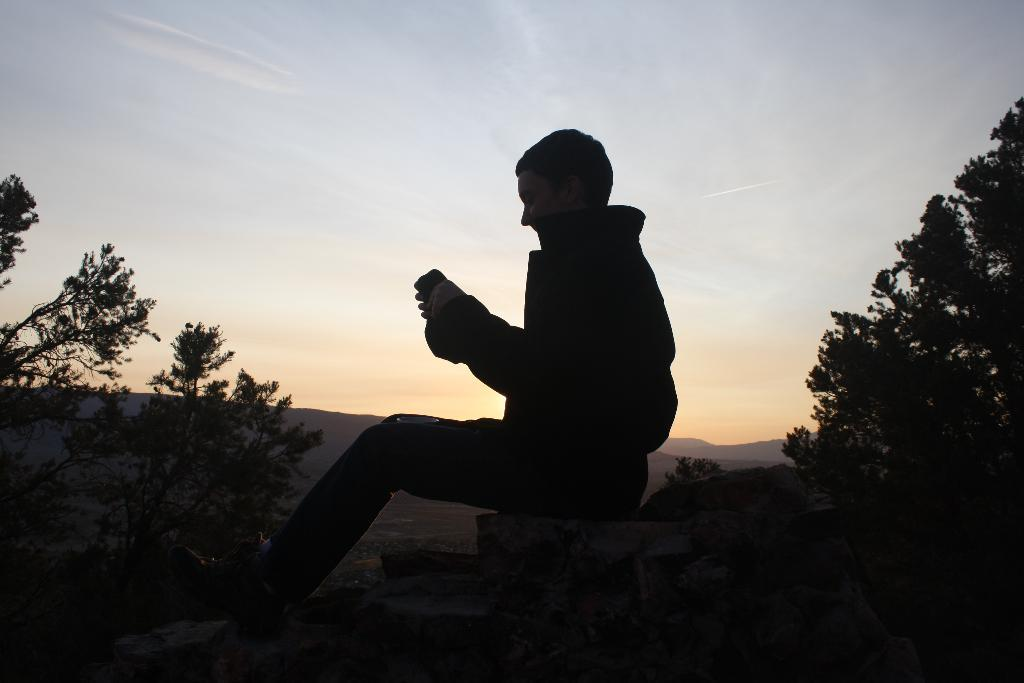What is the person in the image doing? There is a person sitting in the image. What can be seen in the background on either side of the person? There are trees on either side of the person. What type of baseball equipment can be seen on the desk in the image? There is no baseball equipment or desk present in the image. 